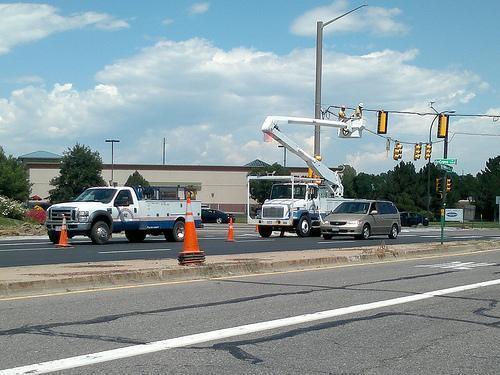How many vehicles are there?
Give a very brief answer. 4. 